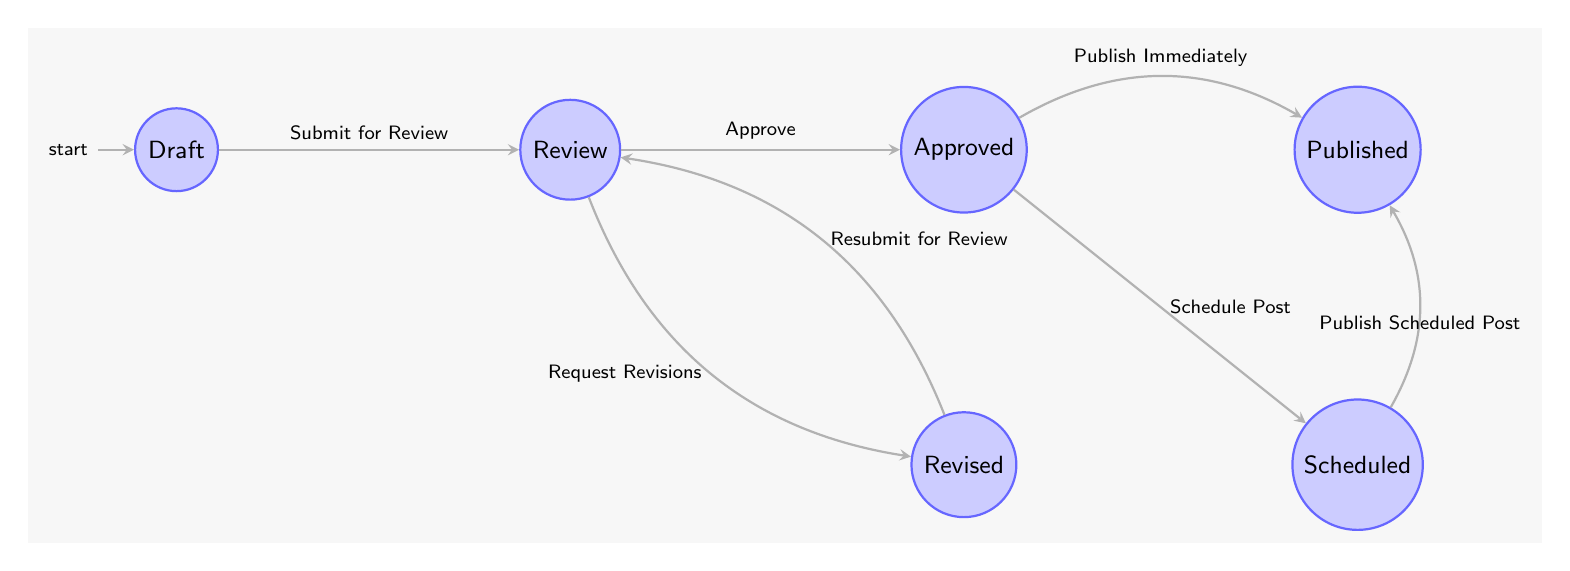What is the initial state of the blog post publishing workflow? The initial state is represented by the starting point in the diagram, which is "Draft."
Answer: Draft How many states are there in the diagram? By counting the distinct states represented in the diagram, we find six: Draft, Review, Revised, Approved, Scheduled, and Published.
Answer: Six Which state comes after "Review" if the post is approved? The transition from "Review" to "Approved" indicates that "Approved" is the state that follows when the post is approved.
Answer: Approved What transition occurs from "Draft" to "Review"? The transition from "Draft" to "Review" is labeled as "Submit for Review," indicating the action that moves the process forward.
Answer: Submit for Review What is the final state of the blog post publishing workflow? The final state, as represented in the diagram, is "Published," which signifies that the blog post is live and available to the public.
Answer: Published If the blog post is in "Approved" state, how can it be made live? From the "Approved" state, it can transition to "Published" through the action "Publish Immediately" or by scheduling it first to "Scheduled" and then publishing. This shows multiple pathways to reach "Published."
Answer: Publish Immediately or Publish Scheduled Post Which state requires revisions before being reviewed again? The state that requires revisions before being reviewed again is “Revised,” as shown by the transition from "Request Revisions” back to "Review."
Answer: Revised How many transitions are outgoing from the "Approved" state? The "Approved" state has two outgoing transitions: one to "Scheduled" and one to "Published." Therefore, there are two outgoing transitions.
Answer: Two What transition leads from "Revised" back to "Review"? The transition that leads from "Revised" back to "Review" is labeled "Resubmit for Review," indicating the process of returning to the previous stage after revisions.
Answer: Resubmit for Review 